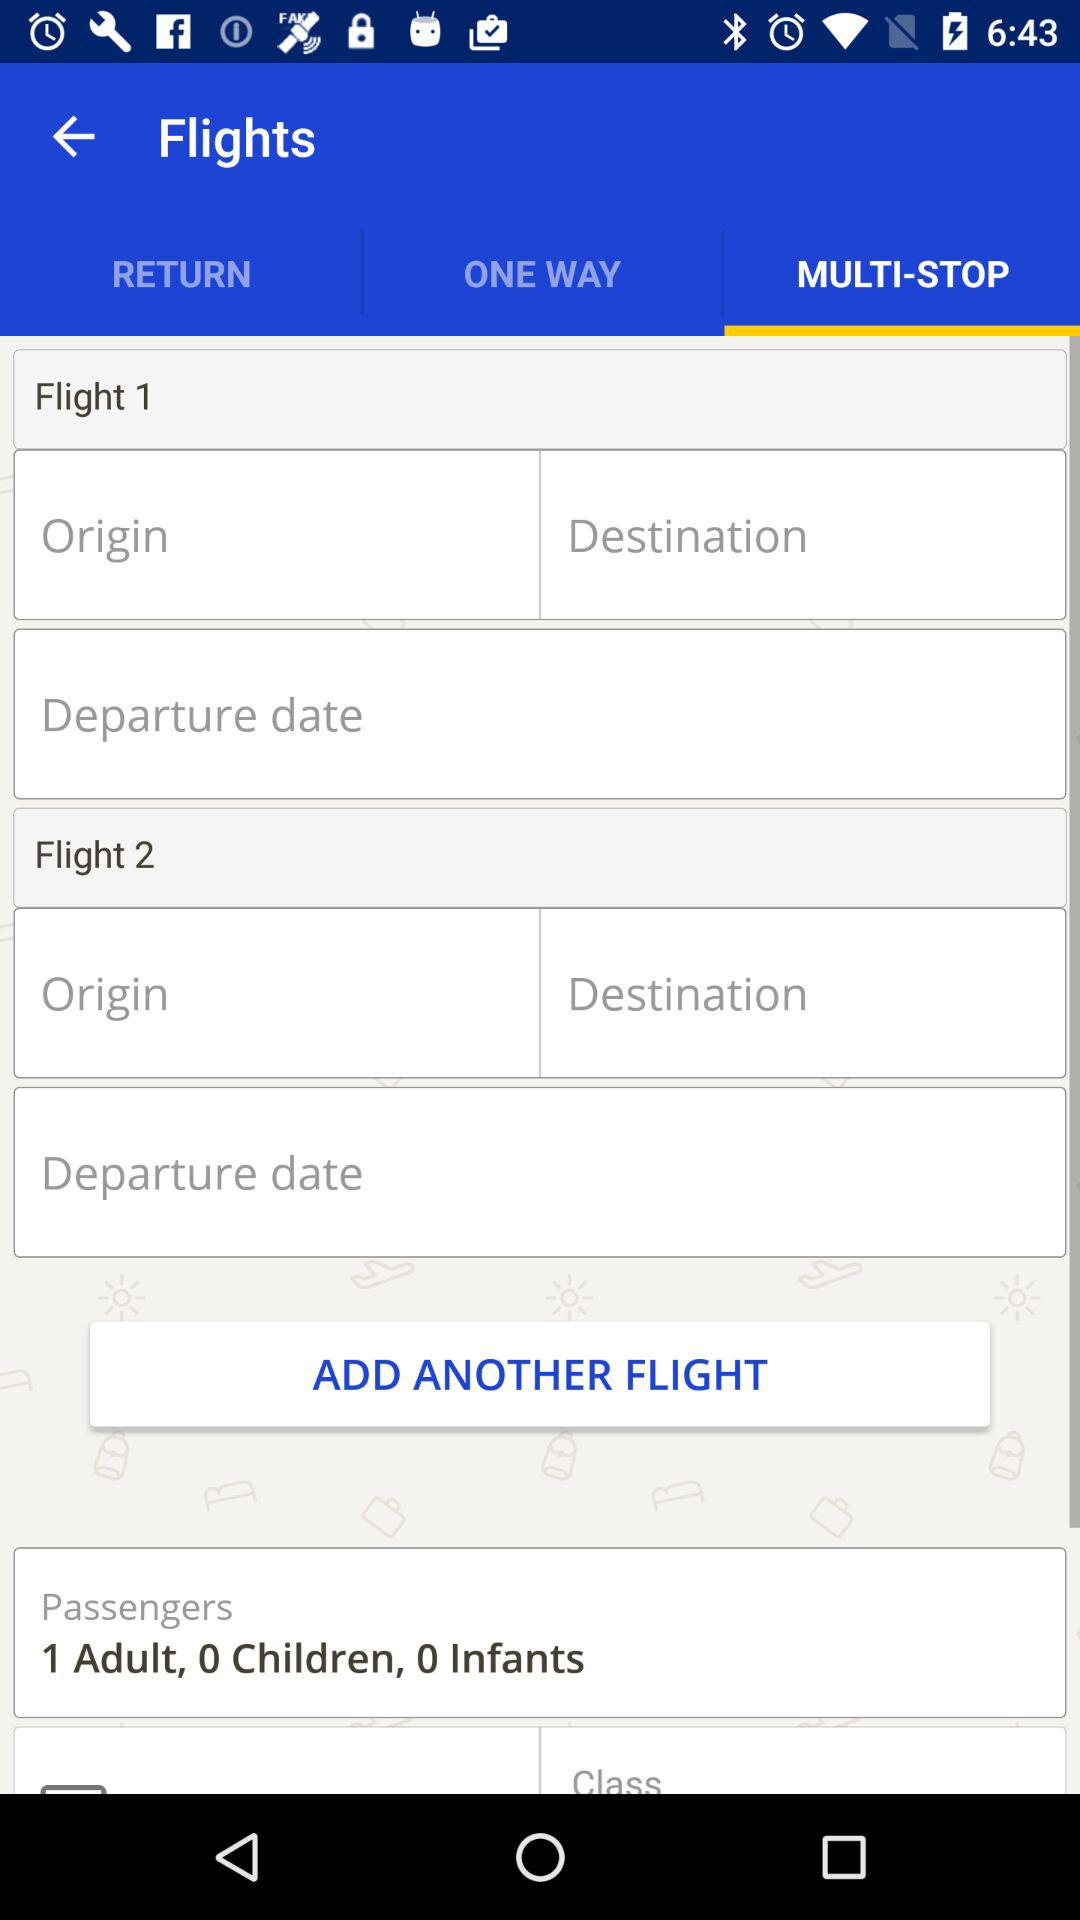How many adults are traveling? There is 1 adult traveling. 